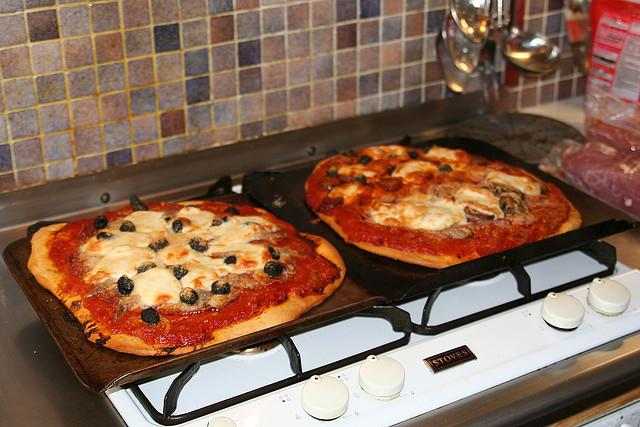Are these pizzas homemade?
Keep it brief. Yes. Is the stove and electric?
Write a very short answer. No. Are there black olives on both pizzas?
Keep it brief. Yes. 